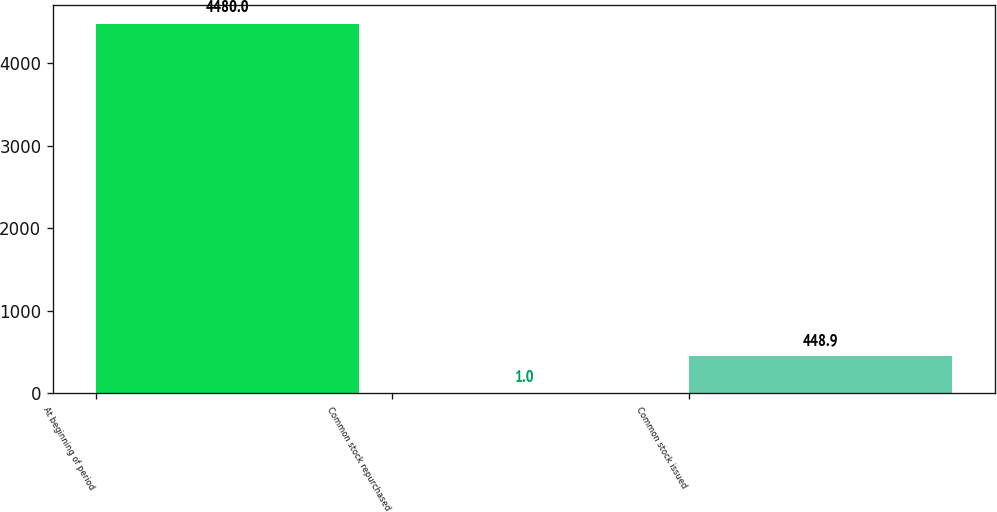Convert chart to OTSL. <chart><loc_0><loc_0><loc_500><loc_500><bar_chart><fcel>At beginning of period<fcel>Common stock repurchased<fcel>Common stock issued<nl><fcel>4480<fcel>1<fcel>448.9<nl></chart> 